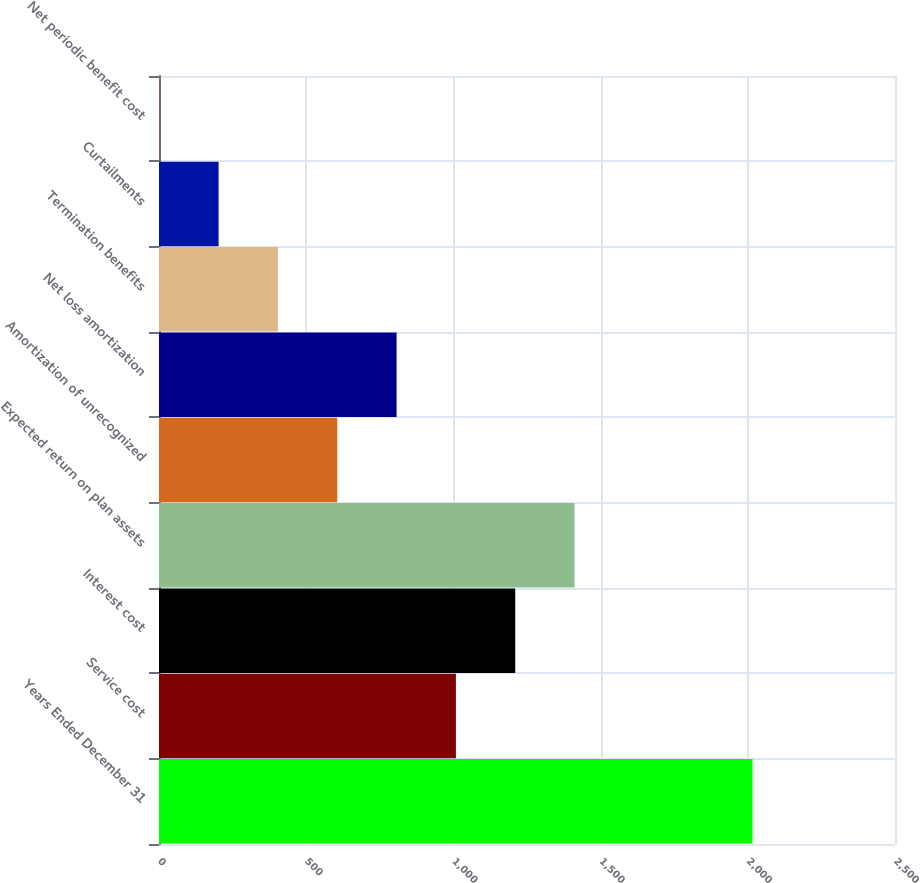Convert chart to OTSL. <chart><loc_0><loc_0><loc_500><loc_500><bar_chart><fcel>Years Ended December 31<fcel>Service cost<fcel>Interest cost<fcel>Expected return on plan assets<fcel>Amortization of unrecognized<fcel>Net loss amortization<fcel>Termination benefits<fcel>Curtailments<fcel>Net periodic benefit cost<nl><fcel>2016<fcel>1008.5<fcel>1210<fcel>1411.5<fcel>605.5<fcel>807<fcel>404<fcel>202.5<fcel>1<nl></chart> 